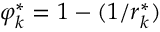<formula> <loc_0><loc_0><loc_500><loc_500>\varphi _ { k } ^ { \ast } = 1 - ( 1 / r _ { k } ^ { \ast } )</formula> 